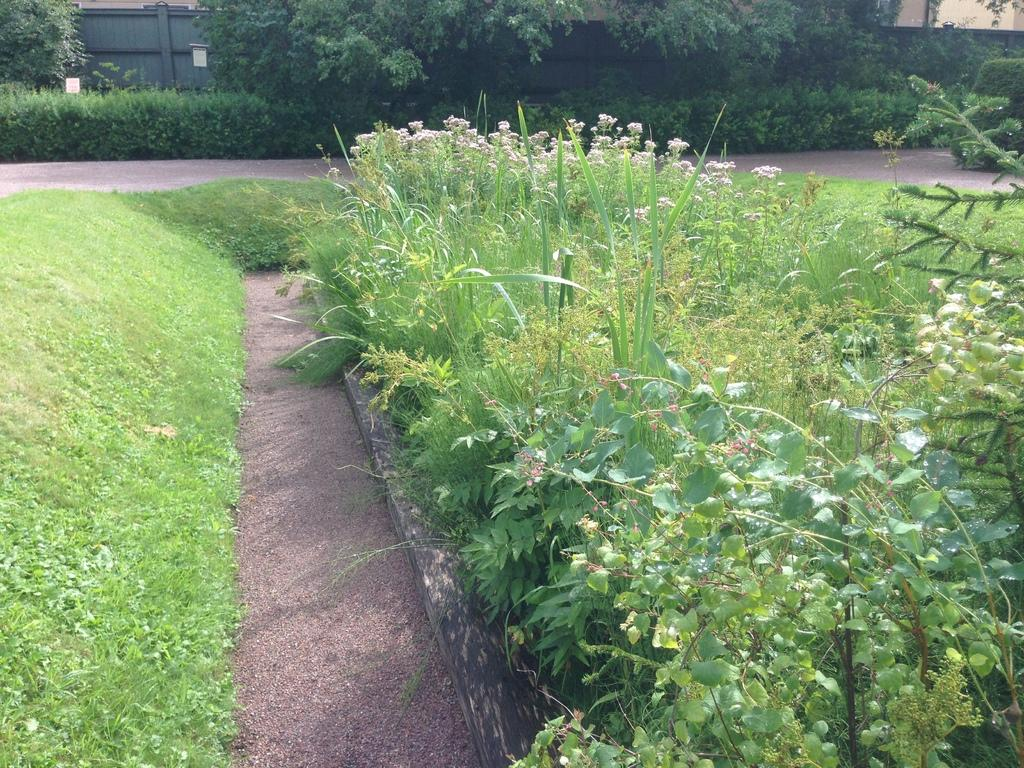What type of vegetation is present in the image? There are trees and plants in the image. What type of structures can be seen in the image? There are boards and sheds in the image. What is visible at the bottom of the image? The ground is visible at the bottom of the image. Can you see the person's smile in the image? There is no person or smile present in the image. Is there any indication of a brother in the image? There is no reference to a brother or any person in the image. 